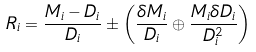<formula> <loc_0><loc_0><loc_500><loc_500>R _ { i } = \frac { M _ { i } - D _ { i } } { D _ { i } } \pm \left ( \frac { \delta M _ { i } } { D _ { i } } \oplus \frac { M _ { i } \delta D _ { i } } { D _ { i } ^ { 2 } } \right )</formula> 